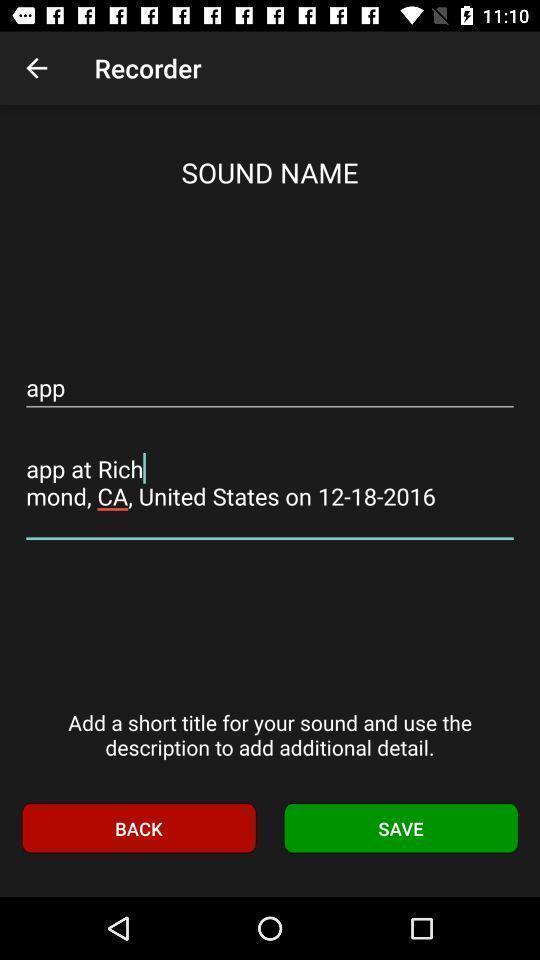Tell me about the visual elements in this screen capture. Screen showing sound name. 